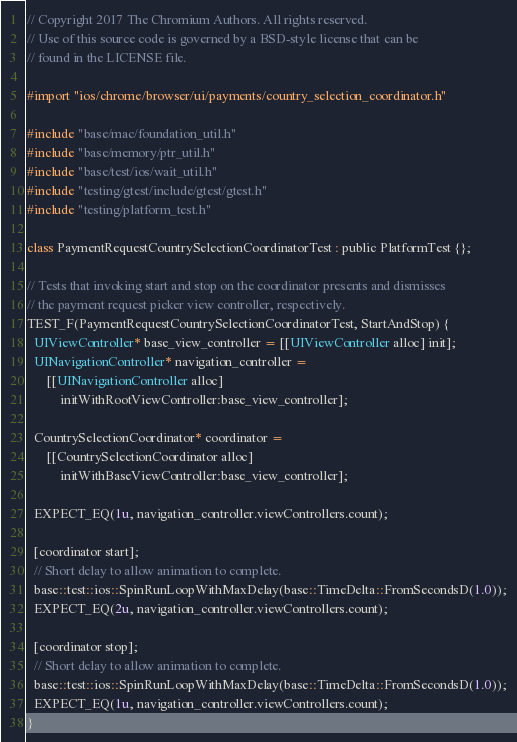Convert code to text. <code><loc_0><loc_0><loc_500><loc_500><_ObjectiveC_>// Copyright 2017 The Chromium Authors. All rights reserved.
// Use of this source code is governed by a BSD-style license that can be
// found in the LICENSE file.

#import "ios/chrome/browser/ui/payments/country_selection_coordinator.h"

#include "base/mac/foundation_util.h"
#include "base/memory/ptr_util.h"
#include "base/test/ios/wait_util.h"
#include "testing/gtest/include/gtest/gtest.h"
#include "testing/platform_test.h"

class PaymentRequestCountrySelectionCoordinatorTest : public PlatformTest {};

// Tests that invoking start and stop on the coordinator presents and dismisses
// the payment request picker view controller, respectively.
TEST_F(PaymentRequestCountrySelectionCoordinatorTest, StartAndStop) {
  UIViewController* base_view_controller = [[UIViewController alloc] init];
  UINavigationController* navigation_controller =
      [[UINavigationController alloc]
          initWithRootViewController:base_view_controller];

  CountrySelectionCoordinator* coordinator =
      [[CountrySelectionCoordinator alloc]
          initWithBaseViewController:base_view_controller];

  EXPECT_EQ(1u, navigation_controller.viewControllers.count);

  [coordinator start];
  // Short delay to allow animation to complete.
  base::test::ios::SpinRunLoopWithMaxDelay(base::TimeDelta::FromSecondsD(1.0));
  EXPECT_EQ(2u, navigation_controller.viewControllers.count);

  [coordinator stop];
  // Short delay to allow animation to complete.
  base::test::ios::SpinRunLoopWithMaxDelay(base::TimeDelta::FromSecondsD(1.0));
  EXPECT_EQ(1u, navigation_controller.viewControllers.count);
}
</code> 